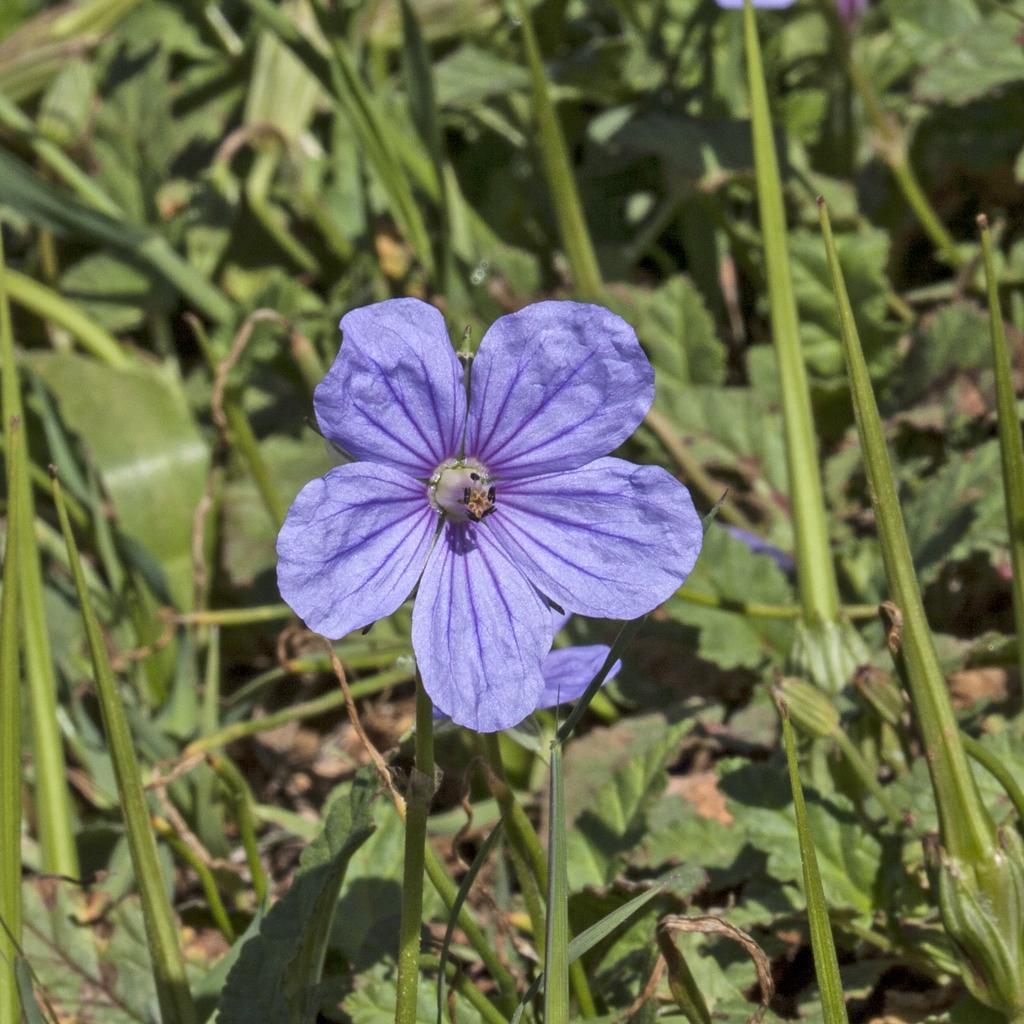Can you describe this image briefly? In this image, we can see few flowers with plant stems and leaves. 